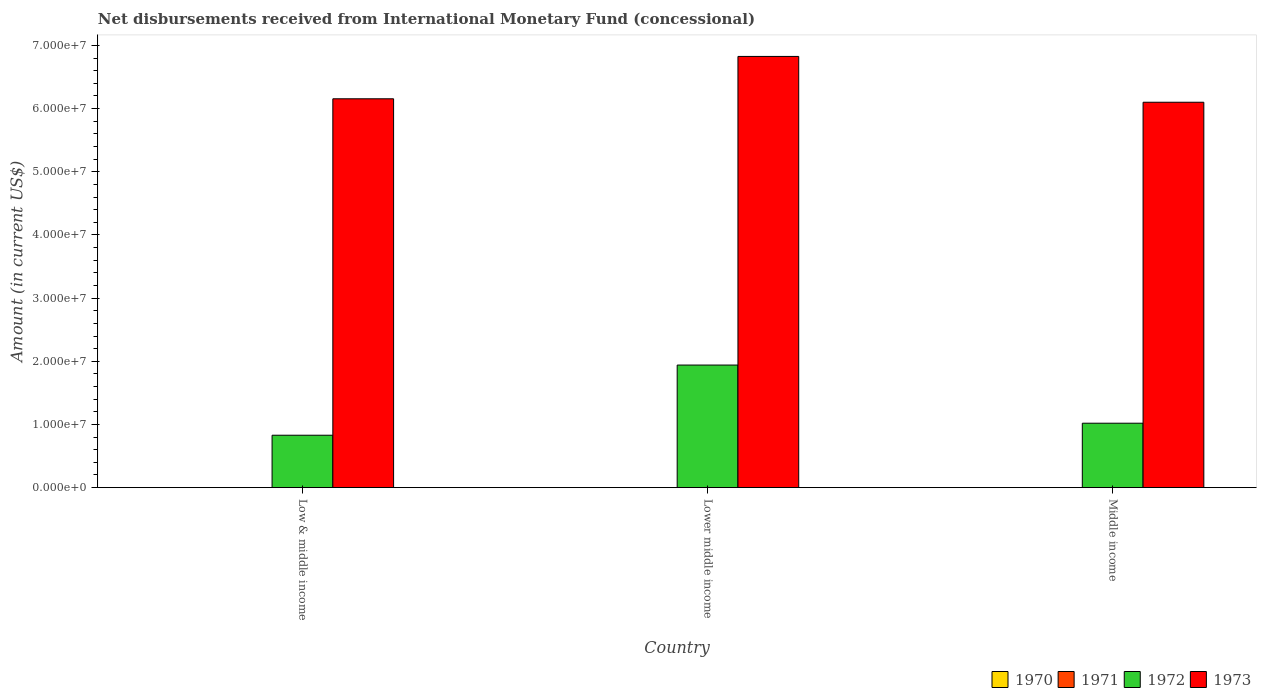How many different coloured bars are there?
Your response must be concise. 2. Are the number of bars per tick equal to the number of legend labels?
Your response must be concise. No. Are the number of bars on each tick of the X-axis equal?
Make the answer very short. Yes. What is the label of the 1st group of bars from the left?
Provide a short and direct response. Low & middle income. In how many cases, is the number of bars for a given country not equal to the number of legend labels?
Ensure brevity in your answer.  3. What is the amount of disbursements received from International Monetary Fund in 1971 in Lower middle income?
Keep it short and to the point. 0. Across all countries, what is the maximum amount of disbursements received from International Monetary Fund in 1972?
Offer a terse response. 1.94e+07. Across all countries, what is the minimum amount of disbursements received from International Monetary Fund in 1973?
Offer a terse response. 6.10e+07. In which country was the amount of disbursements received from International Monetary Fund in 1972 maximum?
Your answer should be very brief. Lower middle income. What is the total amount of disbursements received from International Monetary Fund in 1971 in the graph?
Your answer should be very brief. 0. What is the difference between the amount of disbursements received from International Monetary Fund in 1972 in Lower middle income and that in Middle income?
Ensure brevity in your answer.  9.21e+06. What is the difference between the amount of disbursements received from International Monetary Fund in 1970 in Low & middle income and the amount of disbursements received from International Monetary Fund in 1972 in Lower middle income?
Your answer should be compact. -1.94e+07. What is the average amount of disbursements received from International Monetary Fund in 1973 per country?
Make the answer very short. 6.36e+07. What is the difference between the amount of disbursements received from International Monetary Fund of/in 1973 and amount of disbursements received from International Monetary Fund of/in 1972 in Lower middle income?
Provide a short and direct response. 4.89e+07. In how many countries, is the amount of disbursements received from International Monetary Fund in 1973 greater than 44000000 US$?
Provide a short and direct response. 3. What is the ratio of the amount of disbursements received from International Monetary Fund in 1972 in Lower middle income to that in Middle income?
Provide a succinct answer. 1.9. Is the amount of disbursements received from International Monetary Fund in 1973 in Lower middle income less than that in Middle income?
Make the answer very short. No. Is the difference between the amount of disbursements received from International Monetary Fund in 1973 in Lower middle income and Middle income greater than the difference between the amount of disbursements received from International Monetary Fund in 1972 in Lower middle income and Middle income?
Your answer should be compact. No. What is the difference between the highest and the second highest amount of disbursements received from International Monetary Fund in 1973?
Your response must be concise. -7.25e+06. What is the difference between the highest and the lowest amount of disbursements received from International Monetary Fund in 1973?
Make the answer very short. 7.25e+06. In how many countries, is the amount of disbursements received from International Monetary Fund in 1972 greater than the average amount of disbursements received from International Monetary Fund in 1972 taken over all countries?
Make the answer very short. 1. Is it the case that in every country, the sum of the amount of disbursements received from International Monetary Fund in 1972 and amount of disbursements received from International Monetary Fund in 1970 is greater than the sum of amount of disbursements received from International Monetary Fund in 1971 and amount of disbursements received from International Monetary Fund in 1973?
Make the answer very short. No. What is the difference between two consecutive major ticks on the Y-axis?
Ensure brevity in your answer.  1.00e+07. Are the values on the major ticks of Y-axis written in scientific E-notation?
Provide a succinct answer. Yes. Does the graph contain grids?
Ensure brevity in your answer.  No. Where does the legend appear in the graph?
Keep it short and to the point. Bottom right. How many legend labels are there?
Keep it short and to the point. 4. How are the legend labels stacked?
Offer a very short reply. Horizontal. What is the title of the graph?
Offer a terse response. Net disbursements received from International Monetary Fund (concessional). What is the Amount (in current US$) in 1970 in Low & middle income?
Offer a very short reply. 0. What is the Amount (in current US$) in 1972 in Low & middle income?
Offer a terse response. 8.30e+06. What is the Amount (in current US$) of 1973 in Low & middle income?
Your response must be concise. 6.16e+07. What is the Amount (in current US$) of 1970 in Lower middle income?
Offer a very short reply. 0. What is the Amount (in current US$) of 1971 in Lower middle income?
Provide a succinct answer. 0. What is the Amount (in current US$) of 1972 in Lower middle income?
Offer a terse response. 1.94e+07. What is the Amount (in current US$) in 1973 in Lower middle income?
Make the answer very short. 6.83e+07. What is the Amount (in current US$) in 1970 in Middle income?
Provide a succinct answer. 0. What is the Amount (in current US$) of 1972 in Middle income?
Your answer should be compact. 1.02e+07. What is the Amount (in current US$) of 1973 in Middle income?
Offer a very short reply. 6.10e+07. Across all countries, what is the maximum Amount (in current US$) in 1972?
Your response must be concise. 1.94e+07. Across all countries, what is the maximum Amount (in current US$) of 1973?
Ensure brevity in your answer.  6.83e+07. Across all countries, what is the minimum Amount (in current US$) in 1972?
Keep it short and to the point. 8.30e+06. Across all countries, what is the minimum Amount (in current US$) of 1973?
Keep it short and to the point. 6.10e+07. What is the total Amount (in current US$) of 1970 in the graph?
Offer a terse response. 0. What is the total Amount (in current US$) in 1971 in the graph?
Offer a terse response. 0. What is the total Amount (in current US$) in 1972 in the graph?
Your answer should be very brief. 3.79e+07. What is the total Amount (in current US$) of 1973 in the graph?
Offer a very short reply. 1.91e+08. What is the difference between the Amount (in current US$) in 1972 in Low & middle income and that in Lower middle income?
Offer a very short reply. -1.11e+07. What is the difference between the Amount (in current US$) in 1973 in Low & middle income and that in Lower middle income?
Your answer should be very brief. -6.70e+06. What is the difference between the Amount (in current US$) of 1972 in Low & middle income and that in Middle income?
Give a very brief answer. -1.90e+06. What is the difference between the Amount (in current US$) of 1973 in Low & middle income and that in Middle income?
Offer a terse response. 5.46e+05. What is the difference between the Amount (in current US$) in 1972 in Lower middle income and that in Middle income?
Offer a very short reply. 9.21e+06. What is the difference between the Amount (in current US$) of 1973 in Lower middle income and that in Middle income?
Ensure brevity in your answer.  7.25e+06. What is the difference between the Amount (in current US$) of 1972 in Low & middle income and the Amount (in current US$) of 1973 in Lower middle income?
Offer a very short reply. -6.00e+07. What is the difference between the Amount (in current US$) of 1972 in Low & middle income and the Amount (in current US$) of 1973 in Middle income?
Offer a very short reply. -5.27e+07. What is the difference between the Amount (in current US$) in 1972 in Lower middle income and the Amount (in current US$) in 1973 in Middle income?
Your answer should be very brief. -4.16e+07. What is the average Amount (in current US$) in 1972 per country?
Your answer should be very brief. 1.26e+07. What is the average Amount (in current US$) of 1973 per country?
Offer a terse response. 6.36e+07. What is the difference between the Amount (in current US$) of 1972 and Amount (in current US$) of 1973 in Low & middle income?
Offer a very short reply. -5.33e+07. What is the difference between the Amount (in current US$) in 1972 and Amount (in current US$) in 1973 in Lower middle income?
Ensure brevity in your answer.  -4.89e+07. What is the difference between the Amount (in current US$) of 1972 and Amount (in current US$) of 1973 in Middle income?
Make the answer very short. -5.08e+07. What is the ratio of the Amount (in current US$) of 1972 in Low & middle income to that in Lower middle income?
Offer a terse response. 0.43. What is the ratio of the Amount (in current US$) in 1973 in Low & middle income to that in Lower middle income?
Your response must be concise. 0.9. What is the ratio of the Amount (in current US$) in 1972 in Low & middle income to that in Middle income?
Provide a short and direct response. 0.81. What is the ratio of the Amount (in current US$) in 1973 in Low & middle income to that in Middle income?
Make the answer very short. 1.01. What is the ratio of the Amount (in current US$) in 1972 in Lower middle income to that in Middle income?
Your response must be concise. 1.9. What is the ratio of the Amount (in current US$) in 1973 in Lower middle income to that in Middle income?
Your response must be concise. 1.12. What is the difference between the highest and the second highest Amount (in current US$) of 1972?
Make the answer very short. 9.21e+06. What is the difference between the highest and the second highest Amount (in current US$) in 1973?
Provide a short and direct response. 6.70e+06. What is the difference between the highest and the lowest Amount (in current US$) in 1972?
Your response must be concise. 1.11e+07. What is the difference between the highest and the lowest Amount (in current US$) in 1973?
Your answer should be compact. 7.25e+06. 